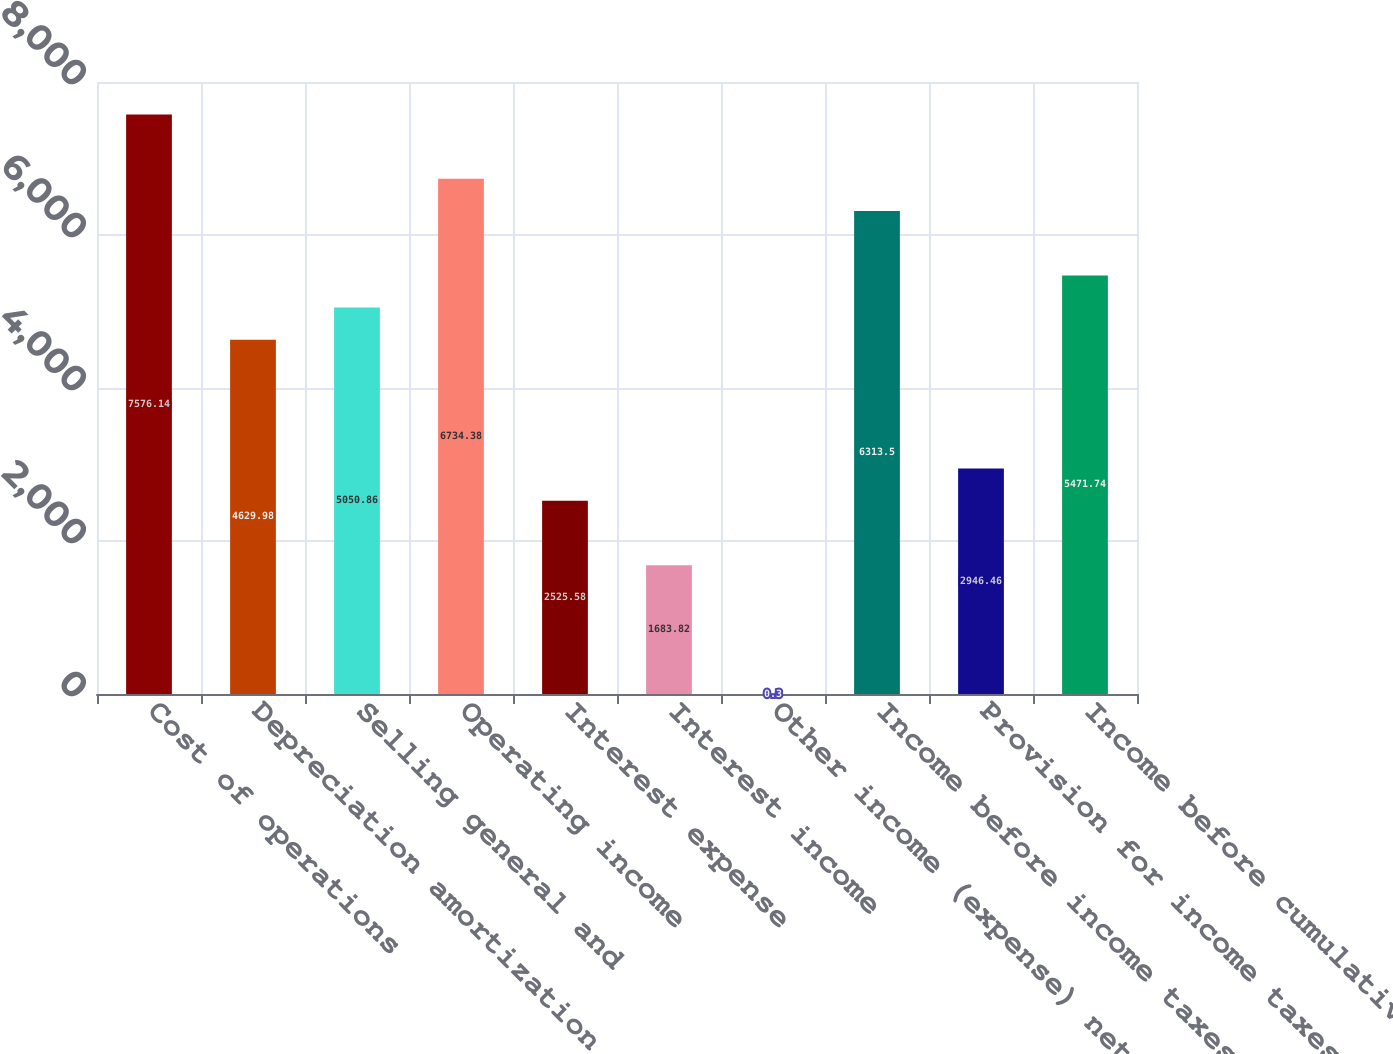Convert chart. <chart><loc_0><loc_0><loc_500><loc_500><bar_chart><fcel>Cost of operations<fcel>Depreciation amortization and<fcel>Selling general and<fcel>Operating income<fcel>Interest expense<fcel>Interest income<fcel>Other income (expense) net<fcel>Income before income taxes<fcel>Provision for income taxes<fcel>Income before cumulative<nl><fcel>7576.14<fcel>4629.98<fcel>5050.86<fcel>6734.38<fcel>2525.58<fcel>1683.82<fcel>0.3<fcel>6313.5<fcel>2946.46<fcel>5471.74<nl></chart> 